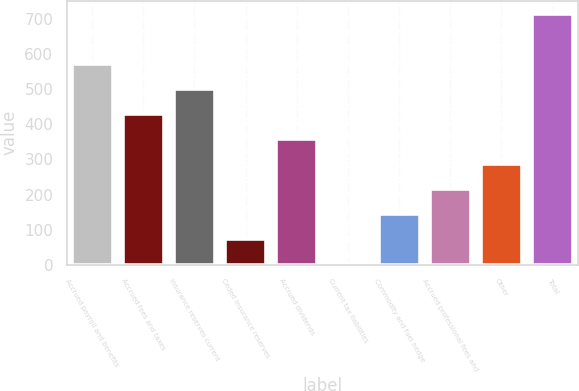<chart> <loc_0><loc_0><loc_500><loc_500><bar_chart><fcel>Accrued payroll and benefits<fcel>Accrued fees and taxes<fcel>Insurance reserves current<fcel>Ceded insurance reserves<fcel>Accrued dividends<fcel>Current tax liabilities<fcel>Commodity and fuel hedge<fcel>Accrued professional fees and<fcel>Other<fcel>Total<nl><fcel>573.38<fcel>430.16<fcel>501.77<fcel>72.11<fcel>358.55<fcel>0.5<fcel>143.72<fcel>215.33<fcel>286.94<fcel>716.6<nl></chart> 